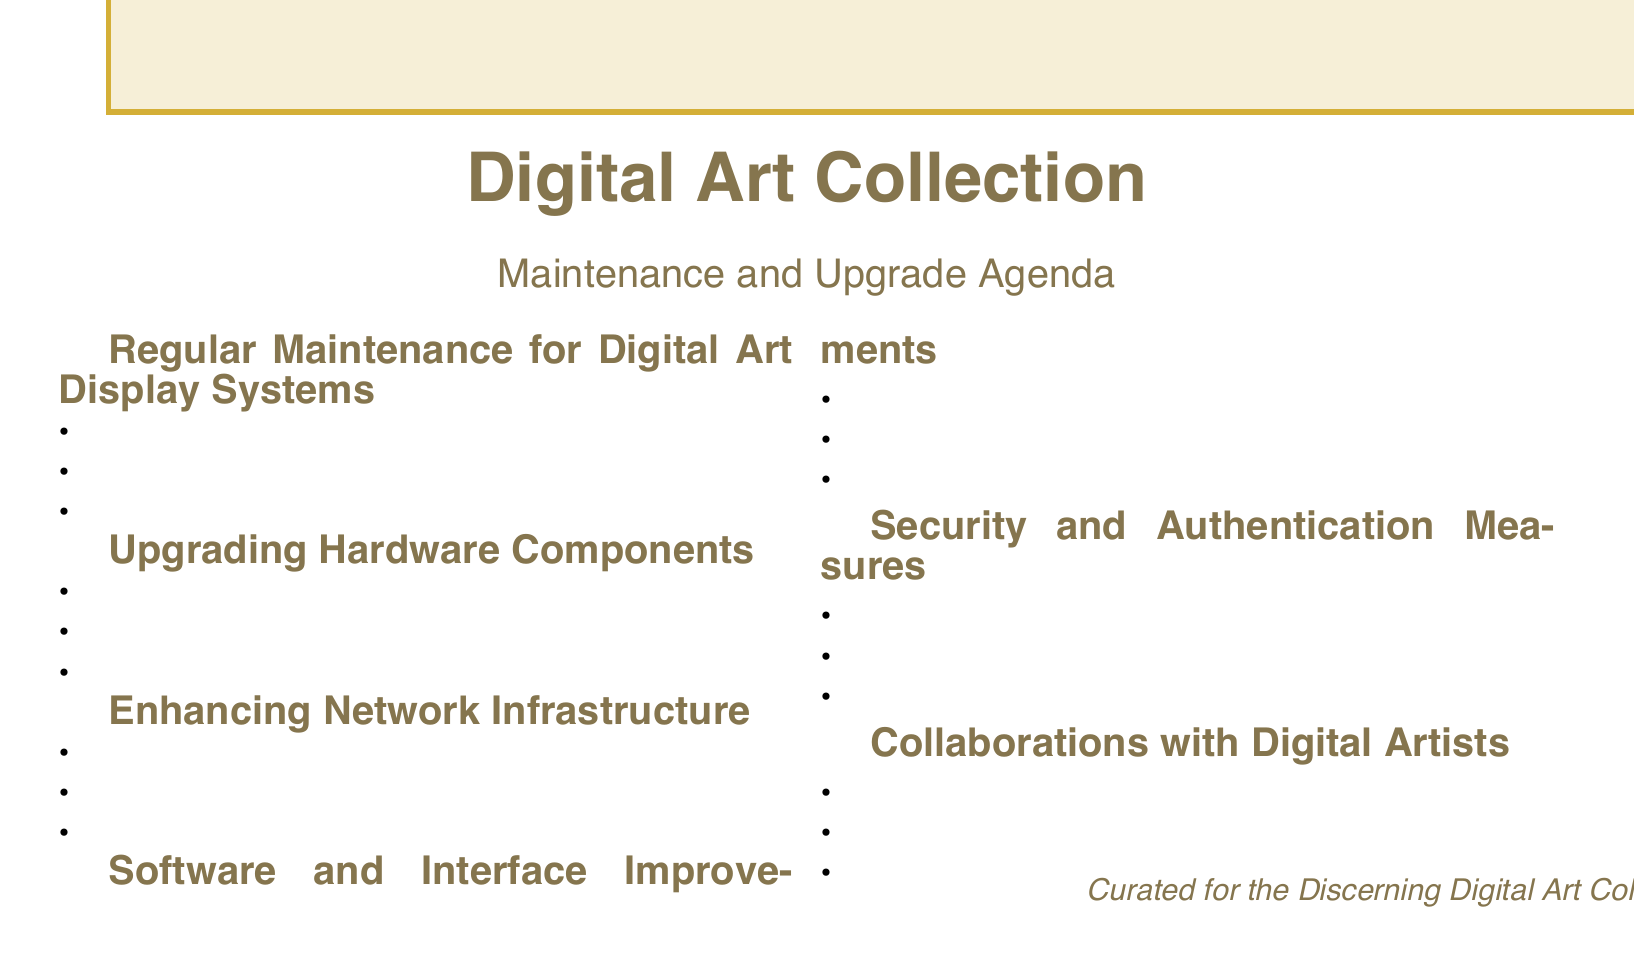What is the first agenda item? The first agenda item listed in the document is "Regular Maintenance for Digital Art Display Systems."
Answer: Regular Maintenance for Digital Art Display Systems Which technology is suggested for enhancing color accuracy? The document mentions "Quantum Dot technology" as a technology for enhanced color accuracy.
Answer: Quantum Dot technology How many subtopics are listed under "Software and Interface Improvements"? There are four subtopics listed under "Software and Interface Improvements."
Answer: 4 What is one of the collaboration opportunities mentioned? The document describes "Commissioning custom interactive installations from TeamLab" as a collaboration opportunity.
Answer: Commissioning custom interactive installations from TeamLab What is recommended for faster art streaming? The agenda suggests "Implementing Wi-Fi 6E" for faster art streaming and downloads.
Answer: Implementing Wi-Fi 6E What security measure includes biometric access? The document outlines "Enhancing biometric access controls for high-value digital pieces" as a security measure.
Answer: Enhancing biometric access controls for high-value digital pieces Which GPU technology is recommended for interactive art pieces? The recommended GPU technology for interactive art pieces is "NVIDIA RTX GPUs."
Answer: NVIDIA RTX GPUs How many total agenda items are there? The document lists a total of six agenda items related to maintenance and upgrades.
Answer: 6 What does the agenda suggest for digital certificates of authenticity? The document recommends "Integrating with Verisart for digital certificates of authenticity."
Answer: Integrating with Verisart for digital certificates of authenticity 